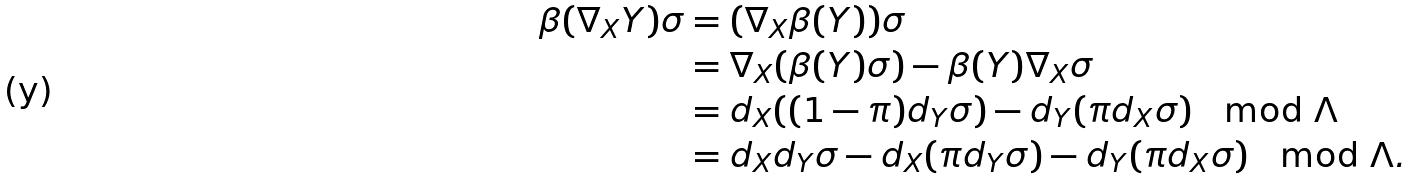<formula> <loc_0><loc_0><loc_500><loc_500>\beta ( \nabla _ { X } Y ) \sigma & = ( \nabla _ { X } \beta ( Y ) ) \sigma \\ & = \nabla _ { X } ( \beta ( Y ) \sigma ) - \beta ( Y ) \nabla _ { X } \sigma \\ & = d _ { X } ( ( 1 - \pi ) d _ { Y } \sigma ) - d _ { Y } ( \pi d _ { X } \sigma ) \mod \Lambda \\ & = d _ { X } d _ { Y } \sigma - d _ { X } ( \pi d _ { Y } \sigma ) - d _ { Y } ( \pi d _ { X } \sigma ) \mod \Lambda .</formula> 